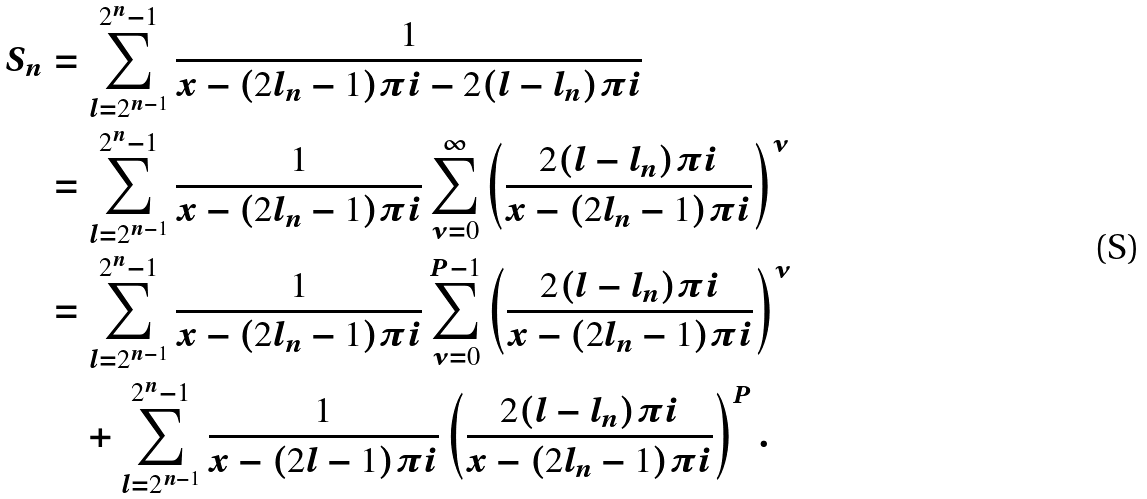<formula> <loc_0><loc_0><loc_500><loc_500>S _ { n } & = \sum _ { l = 2 ^ { n - 1 } } ^ { 2 ^ { n } - 1 } \frac { 1 } { x - ( 2 l _ { n } - 1 ) \pi i - 2 ( l - l _ { n } ) \pi i } \\ & = \sum _ { l = 2 ^ { n - 1 } } ^ { 2 ^ { n } - 1 } \frac { 1 } { x - ( 2 l _ { n } - 1 ) \pi i } \sum _ { \nu = 0 } ^ { \infty } \left ( \frac { 2 ( l - l _ { n } ) \pi i } { x - ( 2 l _ { n } - 1 ) \pi i } \right ) ^ { \nu } \\ & = \sum _ { l = 2 ^ { n - 1 } } ^ { 2 ^ { n } - 1 } \frac { 1 } { x - ( 2 l _ { n } - 1 ) \pi i } \sum _ { \nu = 0 } ^ { P - 1 } \left ( \frac { 2 ( l - l _ { n } ) \pi i } { x - ( 2 l _ { n } - 1 ) \pi i } \right ) ^ { \nu } \\ & \quad + \sum _ { l = 2 ^ { n - 1 } } ^ { 2 ^ { n } - 1 } \frac { 1 } { x - ( 2 l - 1 ) \pi i } \left ( \frac { 2 ( l - l _ { n } ) \pi i } { x - ( 2 l _ { n } - 1 ) \pi i } \right ) ^ { P } .</formula> 